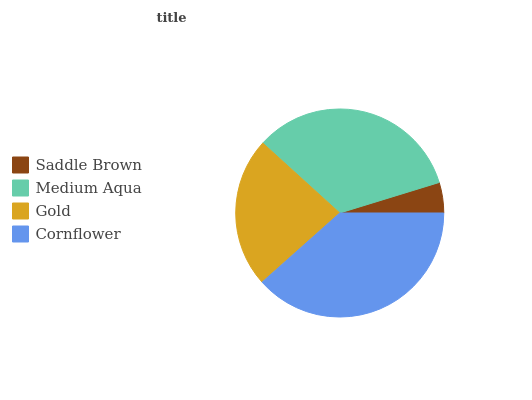Is Saddle Brown the minimum?
Answer yes or no. Yes. Is Cornflower the maximum?
Answer yes or no. Yes. Is Medium Aqua the minimum?
Answer yes or no. No. Is Medium Aqua the maximum?
Answer yes or no. No. Is Medium Aqua greater than Saddle Brown?
Answer yes or no. Yes. Is Saddle Brown less than Medium Aqua?
Answer yes or no. Yes. Is Saddle Brown greater than Medium Aqua?
Answer yes or no. No. Is Medium Aqua less than Saddle Brown?
Answer yes or no. No. Is Medium Aqua the high median?
Answer yes or no. Yes. Is Gold the low median?
Answer yes or no. Yes. Is Gold the high median?
Answer yes or no. No. Is Saddle Brown the low median?
Answer yes or no. No. 